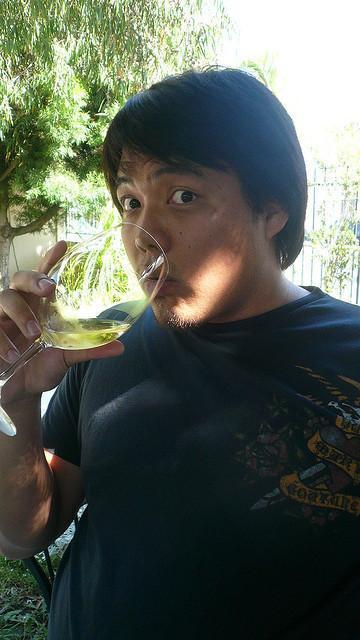How many boats are in this photo?
Give a very brief answer. 0. 